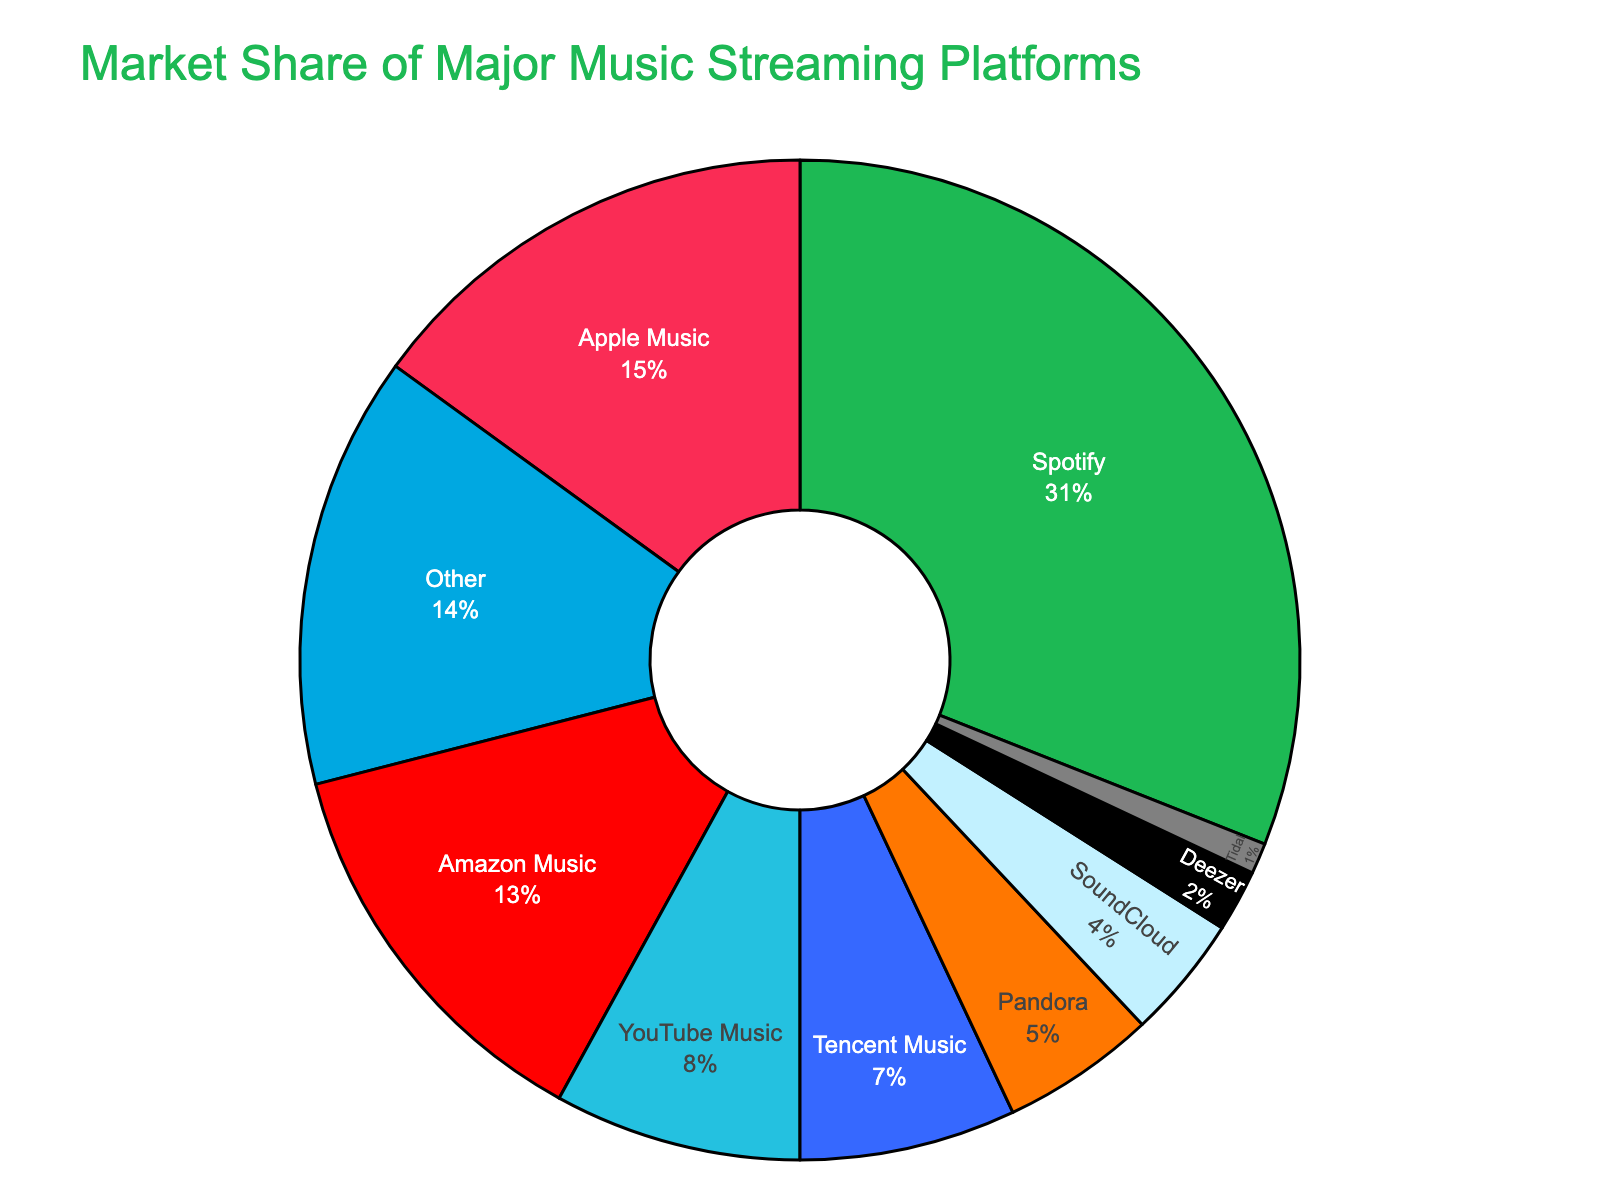Which platform has the highest market share? The platform with the highest market share is easy to identify from the pie chart by observing which portion is the largest.
Answer: Spotify What is the combined market share of Apple Music and Amazon Music? To find the combined market share, add the market shares of Apple Music and Amazon Music: 15 (Apple Music) + 13 (Amazon Music) = 28.
Answer: 28 How much larger is Spotify's market share compared to YouTube Music? Subtract the market share of YouTube Music from Spotify: 31 (Spotify) - 8 (YouTube Music) = 23.
Answer: 23 What percentage of the market is held by platforms other than Spotify and Apple Music? Subtract the combined market share of Spotify and Apple Music from 100: 100 - (31 + 15) = 100 - 46 = 54.
Answer: 54 Which platforms have less than 5% market share each? From the pie chart, observe the platforms with less than 5% each: SoundCloud (4%), Deezer (2%), Tidal (1%).
Answer: SoundCloud, Deezer, Tidal What is the difference in market share between Pandora and Deezer? Subtract the market share of Deezer from Pandora: 5 (Pandora) - 2 (Deezer) = 3.
Answer: 3 How many platforms have a larger market share than 10%? Count the platforms with more than 10% market share: Spotify (31%), Apple Music (15%), Amazon Music (13%). There are three platforms.
Answer: 3 What is the average market share of Pandora, SoundCloud, and Deezer? Sum the market shares of Pandora, SoundCloud, and Deezer and then divide by 3: (5 + 4 + 2) / 3 = 11 / 3 = 3.67.
Answer: 3.67 Which section is represented by the smallest slice and what is its market share? The smallest slice in the pie chart corresponds to Tidal with a market share of 1%.
Answer: Tidal, 1 What is the total market share of YouTube Music and Tencent Music combined? Add the market shares of YouTube Music and Tencent Music: 8 (YouTube Music) + 7 (Tencent Music) = 15.
Answer: 15 